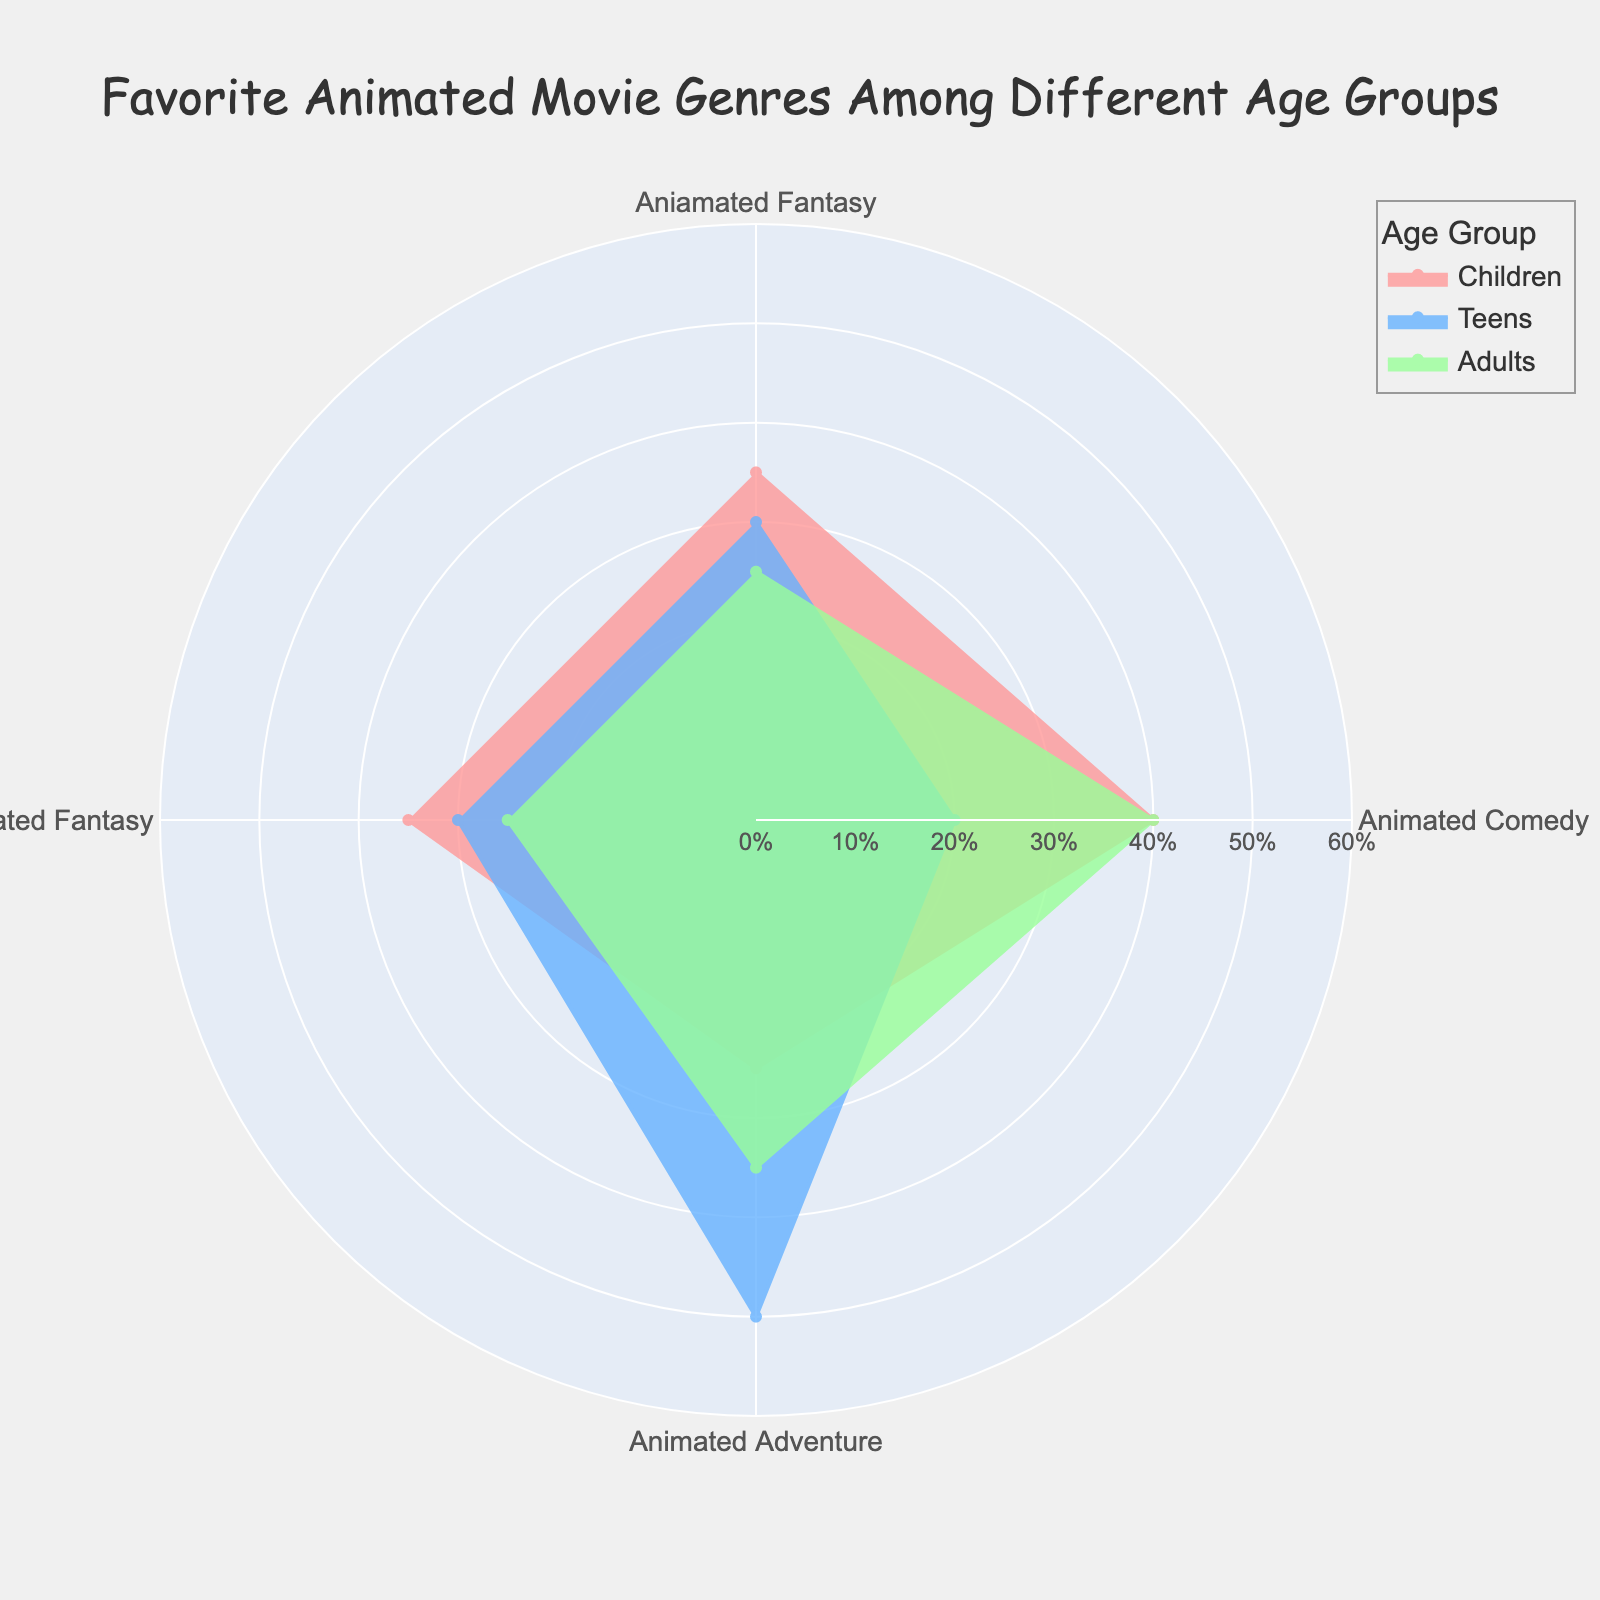What is the title of the plot? The title is usually found at the top of the plot and is meant to summarize the main topic of the visualization. Here, the title conveys the primary focus of the figure.
Answer: Favorite Animated Movie Genres Among Different Age Groups What are the three age groups represented in the rose chart? By looking at the legend or the annotations within the plot, you can identify the distinct age groups that are being compared in the chart.
Answer: Children, Teens, Adults Which genre has the highest favorite percentage for Children? Inspect the radial length of each segment for the Children age group. The segment with the longest length represents the highest percentage.
Answer: Animated Comedy What is the favorite percentage for Adults in the Adult Animation (Anime) genre? Locate the segment corresponding to the Adult Animation (Anime) genre for the Adults age group, then read off the radial value indicated on the plot.
Answer: 35% How does the favorite percentage for Animated Fantasy compare between Teens and Adults? Compare the radial lengths of the Animated Fantasy segments for both Teens and Adults. Determine which is longer to see which group has a higher percentage.
Answer: Teens have a higher percentage What is the total favorite percentage for all genres among Children? Add the favorite percentages for each genre within the Children age group: 35% for Animated Fantasy, 40% for Animated Comedy, and 25% for Animated Adventure.
Answer: 100% Which age group has the greatest preference for Animated Sci-Fi? Look at the radial lengths for the Animated Sci-Fi segments among all age groups represented in the chart, and identify the one with the longest segment.
Answer: Teens What is the average favorite percentage of Animated Comedy for all age groups? Add the percentages for Animated Comedy in each age group: Children (40%), Teens (20%), Adults (40%), then divide by the number of age groups (3).
Answer: 33.33% Between Animated Fantasy and Animated Comedy, which genre has a more varied preference across different age groups? Compare the range of percentages across the age groups for each genre. Determine which genre has a larger range (difference between maximum and minimum percentage).
Answer: Animated Comedy How do the preferences for Animated Comedy and Animated Adventure among Children compare? Look at the radial segments for Animated Comedy and Animated Adventure within the Children age group, and note the lengths to determine which is longer.
Answer: Animated Comedy is preferred more 